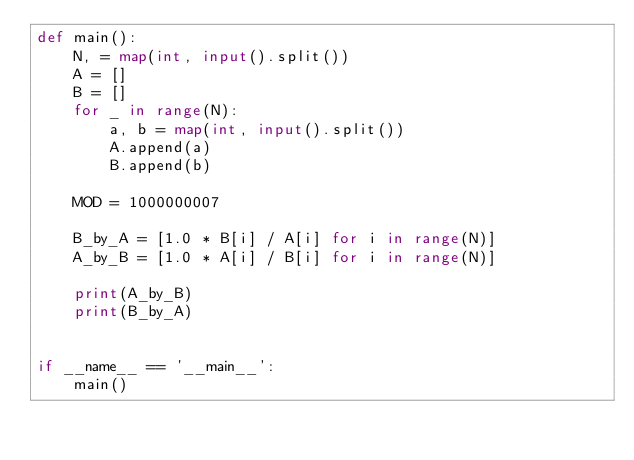Convert code to text. <code><loc_0><loc_0><loc_500><loc_500><_Python_>def main():
    N, = map(int, input().split())
    A = []
    B = []
    for _ in range(N):
        a, b = map(int, input().split())
        A.append(a)
        B.append(b)

    MOD = 1000000007

    B_by_A = [1.0 * B[i] / A[i] for i in range(N)]
    A_by_B = [1.0 * A[i] / B[i] for i in range(N)]

    print(A_by_B)
    print(B_by_A)
    

if __name__ == '__main__':
    main()
</code> 